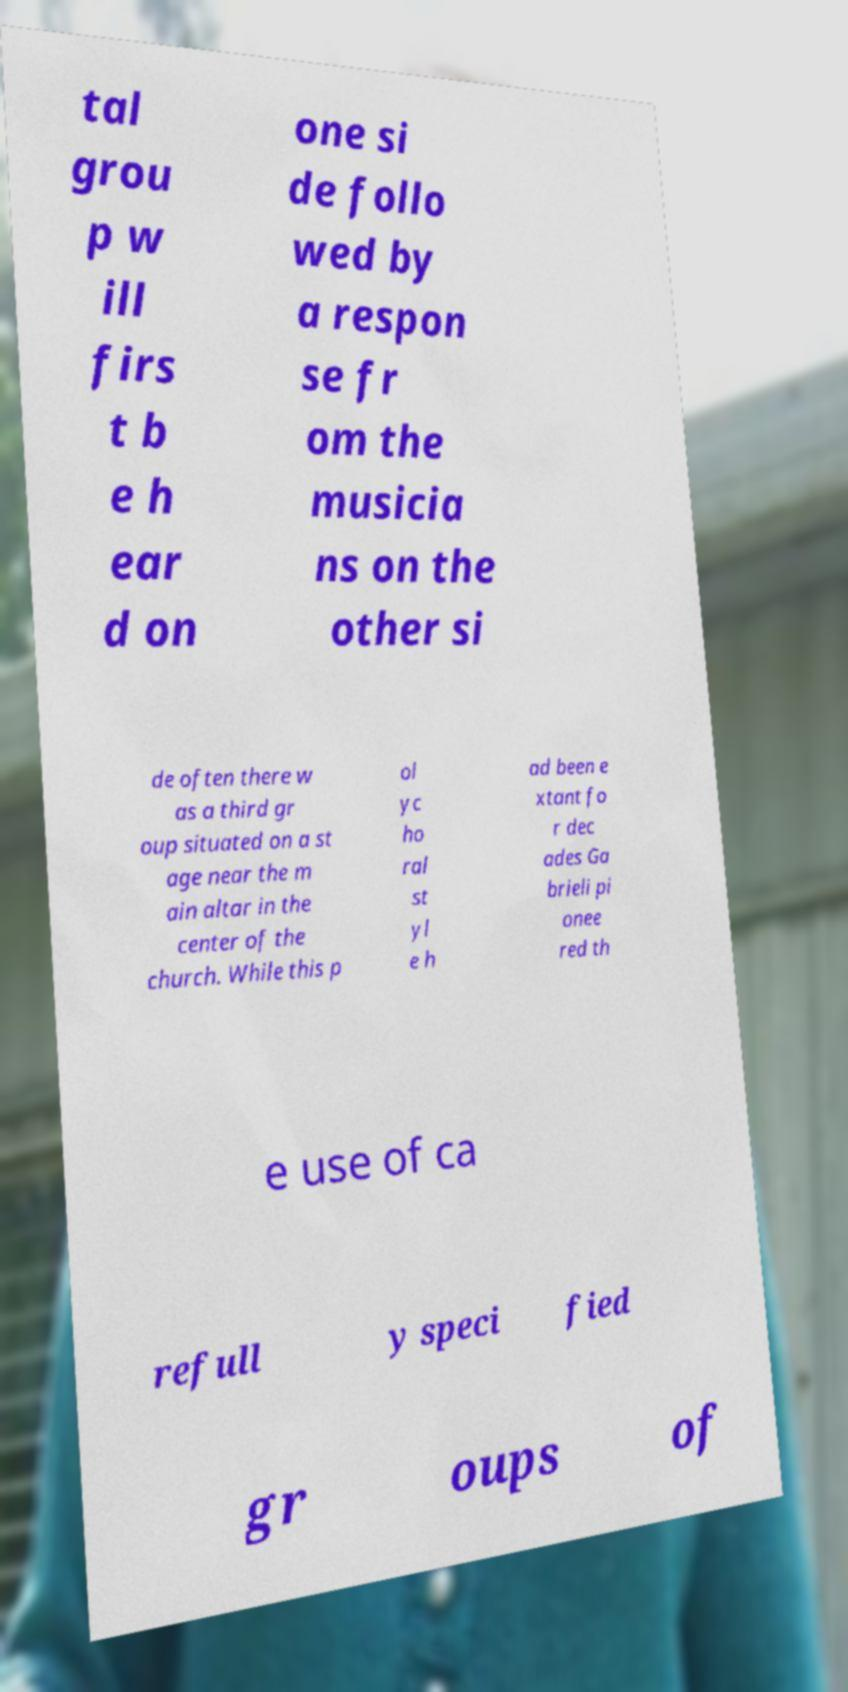For documentation purposes, I need the text within this image transcribed. Could you provide that? tal grou p w ill firs t b e h ear d on one si de follo wed by a respon se fr om the musicia ns on the other si de often there w as a third gr oup situated on a st age near the m ain altar in the center of the church. While this p ol yc ho ral st yl e h ad been e xtant fo r dec ades Ga brieli pi onee red th e use of ca refull y speci fied gr oups of 